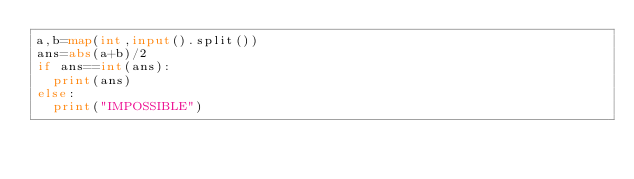<code> <loc_0><loc_0><loc_500><loc_500><_Python_>a,b=map(int,input().split())
ans=abs(a+b)/2
if ans==int(ans):
  print(ans)
else:
  print("IMPOSSIBLE")
</code> 